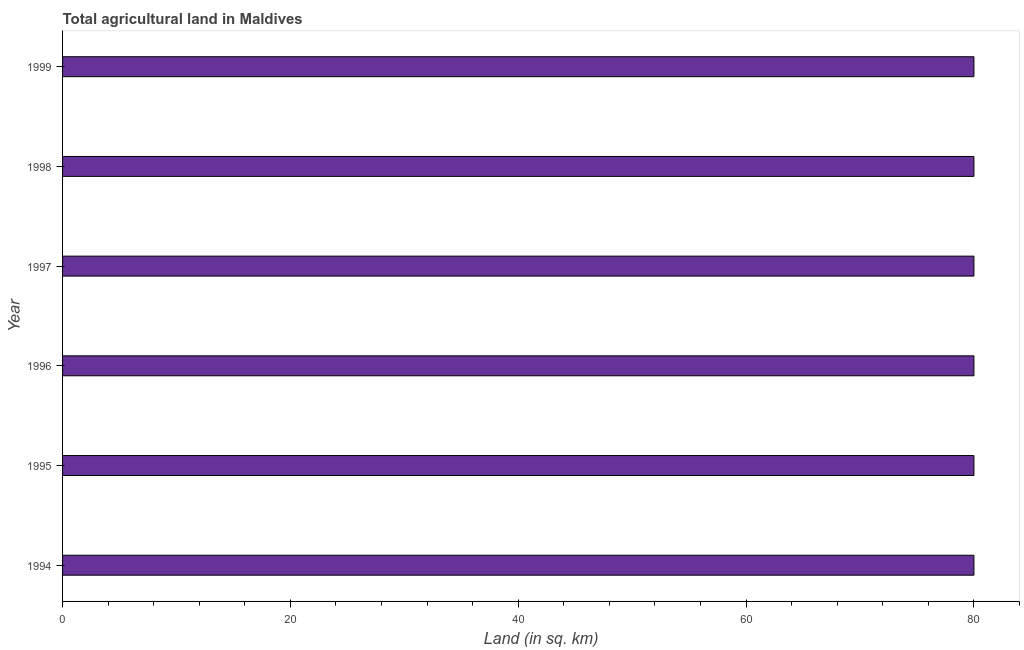Does the graph contain any zero values?
Make the answer very short. No. Does the graph contain grids?
Provide a short and direct response. No. What is the title of the graph?
Make the answer very short. Total agricultural land in Maldives. What is the label or title of the X-axis?
Make the answer very short. Land (in sq. km). What is the label or title of the Y-axis?
Your answer should be compact. Year. What is the agricultural land in 1996?
Provide a short and direct response. 80. Across all years, what is the maximum agricultural land?
Provide a short and direct response. 80. Across all years, what is the minimum agricultural land?
Provide a succinct answer. 80. What is the sum of the agricultural land?
Offer a very short reply. 480. Is the agricultural land in 1994 less than that in 1999?
Your answer should be very brief. No. Is the difference between the agricultural land in 1996 and 1997 greater than the difference between any two years?
Your answer should be compact. Yes. Is the sum of the agricultural land in 1995 and 1999 greater than the maximum agricultural land across all years?
Keep it short and to the point. Yes. What is the difference between the highest and the lowest agricultural land?
Ensure brevity in your answer.  0. How many bars are there?
Provide a succinct answer. 6. How many years are there in the graph?
Give a very brief answer. 6. Are the values on the major ticks of X-axis written in scientific E-notation?
Your answer should be compact. No. What is the Land (in sq. km) of 1995?
Your answer should be very brief. 80. What is the Land (in sq. km) in 1996?
Provide a short and direct response. 80. What is the Land (in sq. km) in 1997?
Make the answer very short. 80. What is the Land (in sq. km) of 1999?
Keep it short and to the point. 80. What is the difference between the Land (in sq. km) in 1994 and 1995?
Your answer should be compact. 0. What is the difference between the Land (in sq. km) in 1994 and 1998?
Your answer should be very brief. 0. What is the difference between the Land (in sq. km) in 1994 and 1999?
Keep it short and to the point. 0. What is the difference between the Land (in sq. km) in 1995 and 1996?
Your answer should be very brief. 0. What is the difference between the Land (in sq. km) in 1995 and 1998?
Give a very brief answer. 0. What is the difference between the Land (in sq. km) in 1996 and 1999?
Keep it short and to the point. 0. What is the difference between the Land (in sq. km) in 1997 and 1998?
Provide a short and direct response. 0. What is the difference between the Land (in sq. km) in 1998 and 1999?
Your answer should be compact. 0. What is the ratio of the Land (in sq. km) in 1994 to that in 1996?
Make the answer very short. 1. What is the ratio of the Land (in sq. km) in 1994 to that in 1997?
Ensure brevity in your answer.  1. What is the ratio of the Land (in sq. km) in 1994 to that in 1998?
Provide a succinct answer. 1. What is the ratio of the Land (in sq. km) in 1994 to that in 1999?
Make the answer very short. 1. What is the ratio of the Land (in sq. km) in 1995 to that in 1998?
Your answer should be very brief. 1. What is the ratio of the Land (in sq. km) in 1996 to that in 1997?
Make the answer very short. 1. What is the ratio of the Land (in sq. km) in 1996 to that in 1998?
Make the answer very short. 1. What is the ratio of the Land (in sq. km) in 1997 to that in 1998?
Offer a very short reply. 1. What is the ratio of the Land (in sq. km) in 1998 to that in 1999?
Your answer should be compact. 1. 